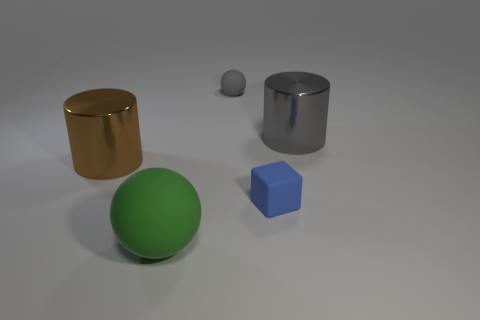Are any big purple metallic cubes visible?
Keep it short and to the point. No. Are there the same number of rubber cubes in front of the large ball and brown metal cubes?
Offer a very short reply. Yes. How many other objects are there of the same shape as the big green object?
Make the answer very short. 1. There is a brown thing; what shape is it?
Ensure brevity in your answer.  Cylinder. Is the green thing made of the same material as the tiny blue block?
Your response must be concise. Yes. Are there the same number of metallic objects that are behind the gray metallic cylinder and large green spheres to the left of the brown metallic cylinder?
Provide a short and direct response. Yes. Is there a large gray cylinder behind the gray object that is in front of the rubber ball that is behind the big brown thing?
Your answer should be compact. No. Do the brown shiny cylinder and the blue block have the same size?
Make the answer very short. No. There is a small object in front of the large metal thing to the right of the large cylinder that is to the left of the tiny blue object; what is its color?
Your answer should be compact. Blue. What number of cylinders have the same color as the tiny matte cube?
Your response must be concise. 0. 